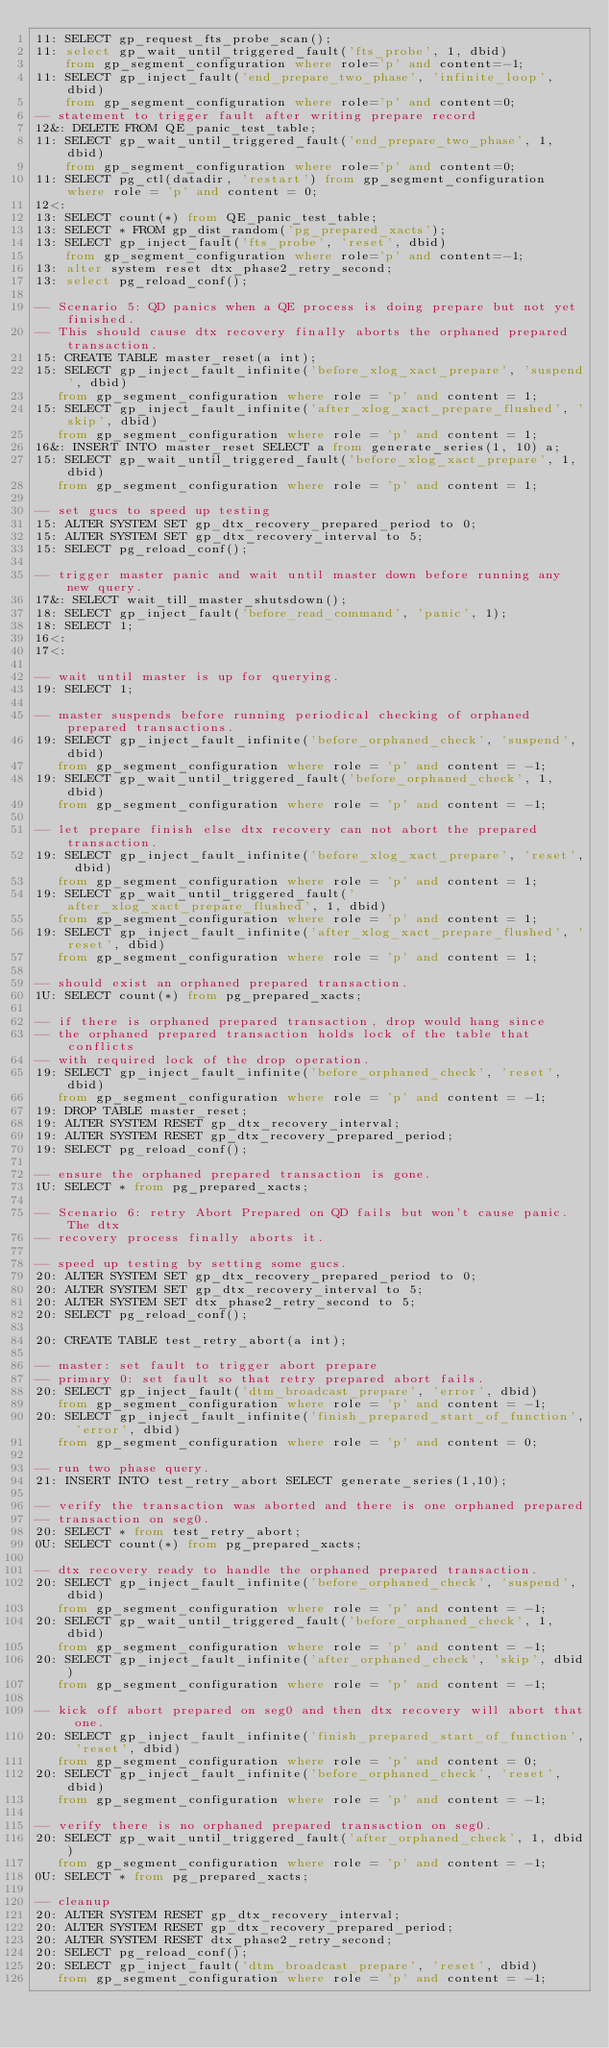Convert code to text. <code><loc_0><loc_0><loc_500><loc_500><_SQL_>11: SELECT gp_request_fts_probe_scan();
11: select gp_wait_until_triggered_fault('fts_probe', 1, dbid)
    from gp_segment_configuration where role='p' and content=-1;
11: SELECT gp_inject_fault('end_prepare_two_phase', 'infinite_loop', dbid)
    from gp_segment_configuration where role='p' and content=0;
-- statement to trigger fault after writing prepare record
12&: DELETE FROM QE_panic_test_table;
11: SELECT gp_wait_until_triggered_fault('end_prepare_two_phase', 1, dbid)
    from gp_segment_configuration where role='p' and content=0;
11: SELECT pg_ctl(datadir, 'restart') from gp_segment_configuration where role = 'p' and content = 0;
12<:
13: SELECT count(*) from QE_panic_test_table;
13: SELECT * FROM gp_dist_random('pg_prepared_xacts');
13: SELECT gp_inject_fault('fts_probe', 'reset', dbid)
    from gp_segment_configuration where role='p' and content=-1;
13: alter system reset dtx_phase2_retry_second;
13: select pg_reload_conf();

-- Scenario 5: QD panics when a QE process is doing prepare but not yet finished.
-- This should cause dtx recovery finally aborts the orphaned prepared transaction.
15: CREATE TABLE master_reset(a int);
15: SELECT gp_inject_fault_infinite('before_xlog_xact_prepare', 'suspend', dbid)
   from gp_segment_configuration where role = 'p' and content = 1;
15: SELECT gp_inject_fault_infinite('after_xlog_xact_prepare_flushed', 'skip', dbid)
   from gp_segment_configuration where role = 'p' and content = 1;
16&: INSERT INTO master_reset SELECT a from generate_series(1, 10) a;
15: SELECT gp_wait_until_triggered_fault('before_xlog_xact_prepare', 1, dbid)
   from gp_segment_configuration where role = 'p' and content = 1;

-- set gucs to speed up testing
15: ALTER SYSTEM SET gp_dtx_recovery_prepared_period to 0;
15: ALTER SYSTEM SET gp_dtx_recovery_interval to 5;
15: SELECT pg_reload_conf();

-- trigger master panic and wait until master down before running any new query.
17&: SELECT wait_till_master_shutsdown();
18: SELECT gp_inject_fault('before_read_command', 'panic', 1);
18: SELECT 1;
16<:
17<:

-- wait until master is up for querying.
19: SELECT 1;

-- master suspends before running periodical checking of orphaned prepared transactions.
19: SELECT gp_inject_fault_infinite('before_orphaned_check', 'suspend', dbid)
   from gp_segment_configuration where role = 'p' and content = -1;
19: SELECT gp_wait_until_triggered_fault('before_orphaned_check', 1, dbid)
   from gp_segment_configuration where role = 'p' and content = -1;

-- let prepare finish else dtx recovery can not abort the prepared transaction.
19: SELECT gp_inject_fault_infinite('before_xlog_xact_prepare', 'reset', dbid)
   from gp_segment_configuration where role = 'p' and content = 1;
19: SELECT gp_wait_until_triggered_fault('after_xlog_xact_prepare_flushed', 1, dbid)
   from gp_segment_configuration where role = 'p' and content = 1;
19: SELECT gp_inject_fault_infinite('after_xlog_xact_prepare_flushed', 'reset', dbid)
   from gp_segment_configuration where role = 'p' and content = 1;

-- should exist an orphaned prepared transaction.
1U: SELECT count(*) from pg_prepared_xacts;

-- if there is orphaned prepared transaction, drop would hang since
-- the orphaned prepared transaction holds lock of the table that conflicts
-- with required lock of the drop operation.
19: SELECT gp_inject_fault_infinite('before_orphaned_check', 'reset', dbid)
   from gp_segment_configuration where role = 'p' and content = -1;
19: DROP TABLE master_reset;
19: ALTER SYSTEM RESET gp_dtx_recovery_interval;
19: ALTER SYSTEM RESET gp_dtx_recovery_prepared_period;
19: SELECT pg_reload_conf();

-- ensure the orphaned prepared transaction is gone.
1U: SELECT * from pg_prepared_xacts;

-- Scenario 6: retry Abort Prepared on QD fails but won't cause panic. The dtx
-- recovery process finally aborts it.

-- speed up testing by setting some gucs.
20: ALTER SYSTEM SET gp_dtx_recovery_prepared_period to 0;
20: ALTER SYSTEM SET gp_dtx_recovery_interval to 5;
20: ALTER SYSTEM SET dtx_phase2_retry_second to 5;
20: SELECT pg_reload_conf();

20: CREATE TABLE test_retry_abort(a int);

-- master: set fault to trigger abort prepare
-- primary 0: set fault so that retry prepared abort fails.
20: SELECT gp_inject_fault('dtm_broadcast_prepare', 'error', dbid)
   from gp_segment_configuration where role = 'p' and content = -1;
20: SELECT gp_inject_fault_infinite('finish_prepared_start_of_function', 'error', dbid)
   from gp_segment_configuration where role = 'p' and content = 0;

-- run two phase query.
21: INSERT INTO test_retry_abort SELECT generate_series(1,10);

-- verify the transaction was aborted and there is one orphaned prepared
-- transaction on seg0.
20: SELECT * from test_retry_abort;
0U: SELECT count(*) from pg_prepared_xacts;

-- dtx recovery ready to handle the orphaned prepared transaction.
20: SELECT gp_inject_fault_infinite('before_orphaned_check', 'suspend', dbid)
   from gp_segment_configuration where role = 'p' and content = -1;
20: SELECT gp_wait_until_triggered_fault('before_orphaned_check', 1, dbid)
   from gp_segment_configuration where role = 'p' and content = -1;
20: SELECT gp_inject_fault_infinite('after_orphaned_check', 'skip', dbid)
   from gp_segment_configuration where role = 'p' and content = -1;

-- kick off abort prepared on seg0 and then dtx recovery will abort that one.
20: SELECT gp_inject_fault_infinite('finish_prepared_start_of_function', 'reset', dbid)
   from gp_segment_configuration where role = 'p' and content = 0;
20: SELECT gp_inject_fault_infinite('before_orphaned_check', 'reset', dbid)
   from gp_segment_configuration where role = 'p' and content = -1;

-- verify there is no orphaned prepared transaction on seg0.
20: SELECT gp_wait_until_triggered_fault('after_orphaned_check', 1, dbid)
   from gp_segment_configuration where role = 'p' and content = -1;
0U: SELECT * from pg_prepared_xacts;

-- cleanup
20: ALTER SYSTEM RESET gp_dtx_recovery_interval;
20: ALTER SYSTEM RESET gp_dtx_recovery_prepared_period;
20: ALTER SYSTEM RESET dtx_phase2_retry_second;
20: SELECT pg_reload_conf();
20: SELECT gp_inject_fault('dtm_broadcast_prepare', 'reset', dbid)
   from gp_segment_configuration where role = 'p' and content = -1;</code> 